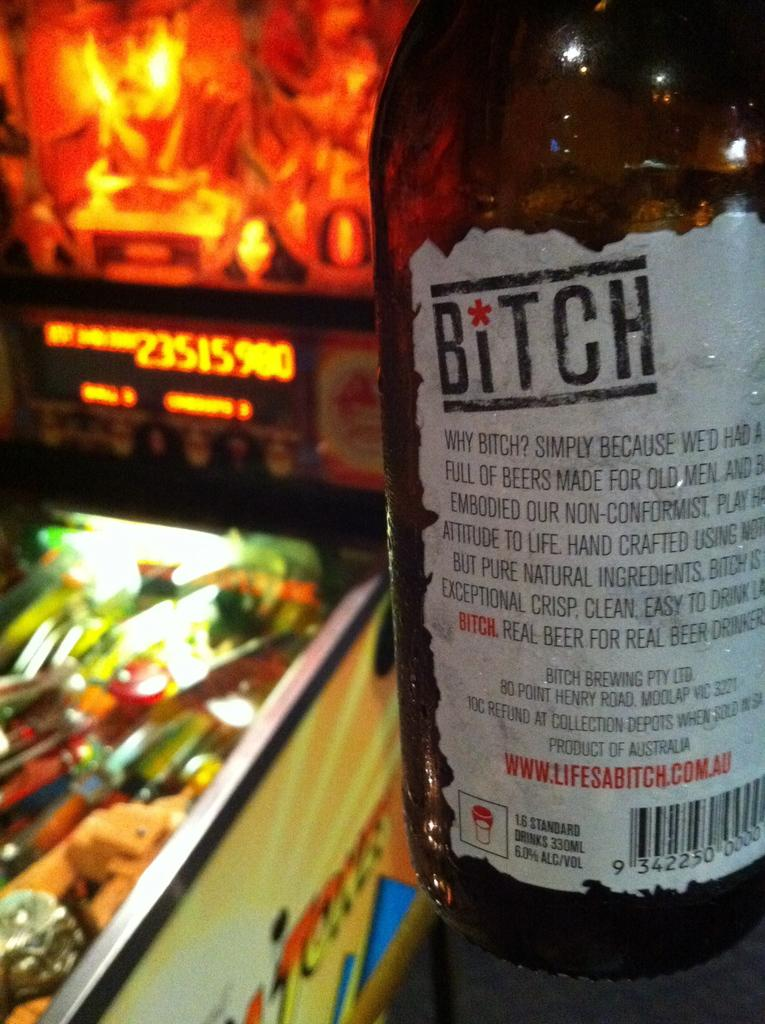What object is present in the image? There is a bottle in the image. What feature does the bottle have? The bottle has a label. What can be found on the label? The label contains text. What type of ornament is hanging from the bottle in the image? There is no ornament hanging from the bottle in the image; it only has a label with text. Is there a scarf wrapped around the bottle in the image? No, there is no scarf wrapped around the bottle in the image. 